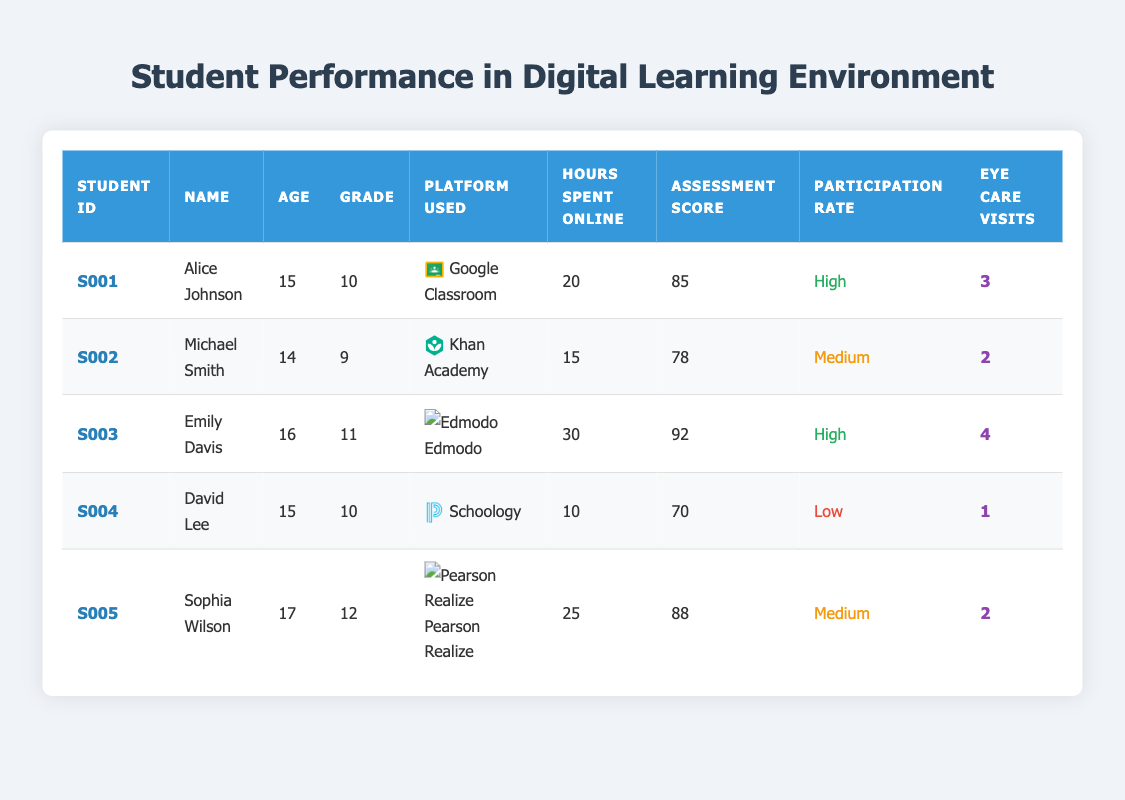What is the highest Assessment Score in the table? The highest Assessment Score can be found by scanning the "Assessment Score" column. The scores for each student are: 85, 78, 92, 70, and 88. The highest value among these is 92.
Answer: 92 How many hours did David Lee spend online? By looking for David Lee's row, we can find the value listed under "Hours Spent Online." It shows that David Lee spent 10 hours online.
Answer: 10 Which student has a High Participation Rate? To find students with a High Participation Rate, we can check the "Participation Rate" column. The students with a High Participation Rate are Alice Johnson and Emily Davis.
Answer: Alice Johnson, Emily Davis What is the average number of Eye Care Visits for students? To calculate the average number of Eye Care Visits, we first sum the visits: 3 + 2 + 4 + 1 + 2 = 12. Then, we divide by the number of students: 12 / 5 = 2.4.
Answer: 2.4 Is there a student who spent more than 25 hours online and has a High Participation Rate? We need to check the "Hours Spent Online" and "Participation Rate" columns. The students who spent more than 25 hours online are Emily Davis (30 hours). She also has a High Participation Rate. Therefore, the statement is true.
Answer: Yes Which student has the lowest Assessment Score and what is that score? Looking at the "Assessment Score" column, David Lee has the lowest score at 70.
Answer: David Lee, 70 What is the total number of Eye Care Visits for all students? We add the number of Eye Care Visits for all five students: 3 + 2 + 4 + 1 + 2 = 12.
Answer: 12 How many students use Google Classroom in this dataset? The "Platform Used" column shows that only Alice Johnson uses Google Classroom. Therefore, there is one student using this platform.
Answer: 1 What is the difference in Assessment Scores between the highest and lowest performing students? The highest score is 92 (Emily Davis) and the lowest is 70 (David Lee). The difference is calculated as 92 - 70 = 22.
Answer: 22 